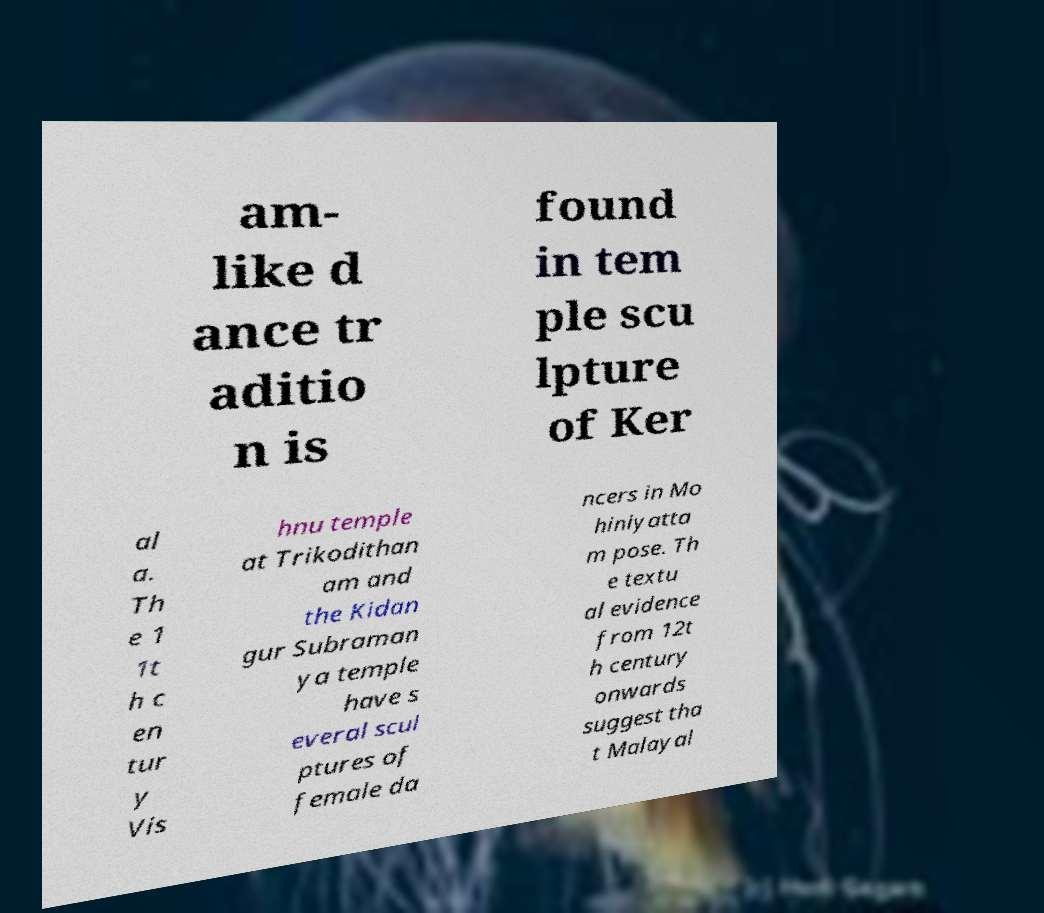Could you extract and type out the text from this image? am- like d ance tr aditio n is found in tem ple scu lpture of Ker al a. Th e 1 1t h c en tur y Vis hnu temple at Trikodithan am and the Kidan gur Subraman ya temple have s everal scul ptures of female da ncers in Mo hiniyatta m pose. Th e textu al evidence from 12t h century onwards suggest tha t Malayal 